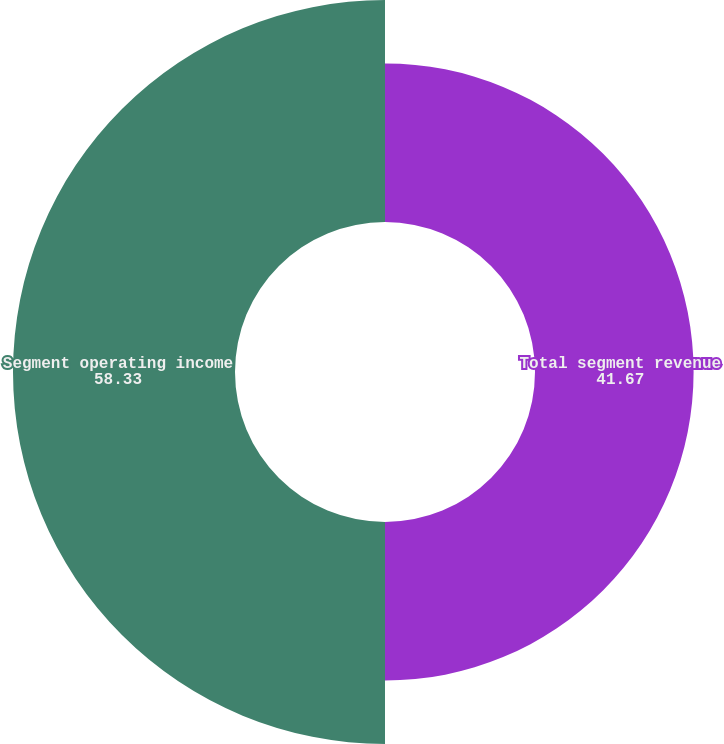Convert chart. <chart><loc_0><loc_0><loc_500><loc_500><pie_chart><fcel>Total segment revenue<fcel>Segment operating income<nl><fcel>41.67%<fcel>58.33%<nl></chart> 